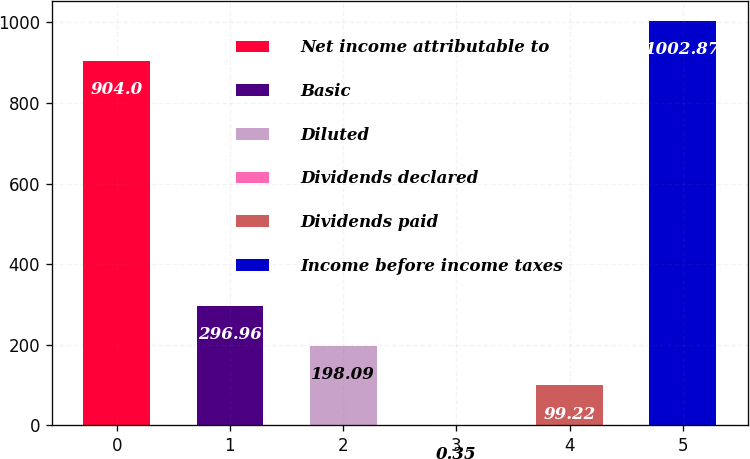Convert chart. <chart><loc_0><loc_0><loc_500><loc_500><bar_chart><fcel>Net income attributable to<fcel>Basic<fcel>Diluted<fcel>Dividends declared<fcel>Dividends paid<fcel>Income before income taxes<nl><fcel>904<fcel>296.96<fcel>198.09<fcel>0.35<fcel>99.22<fcel>1002.87<nl></chart> 